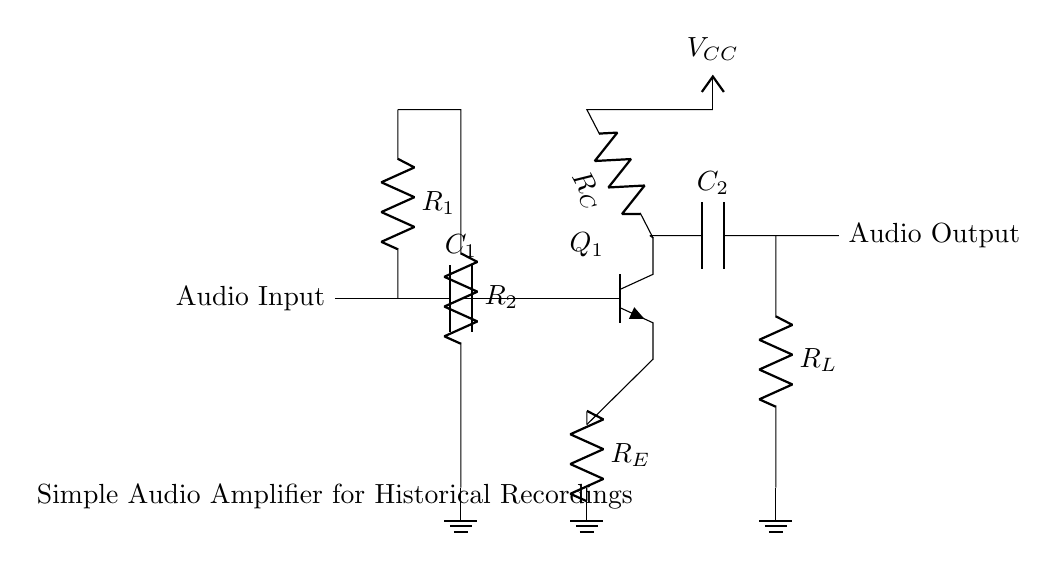What component is used to couple the audio input? The coupling capacitor, labeled as C1, connects the audio input to the transistor, allowing AC signals to pass while blocking DC components.
Answer: C1 What is the configuration of the transistor in this circuit? The circuit includes an NPN transistor (noted as Q1), which is often used in common-emitter configuration for amplification purposes. This setup means the emitter is grounded, and the input is applied at the base for signal amplification.
Answer: NPN What is the role of resistor R_E? R_E, the emitter resistor, helps stabilize the biasing of the transistor by providing negative feedback, which also sets the gain and determines the output impedance of the amplifier.
Answer: Stabilization How many resistors are present in this circuit? The components list shows three resistors: R_E for emitter, R_C for collector, and R_1 and R_2 in the biasing network. Counting gives a total of three resistors overall.
Answer: Three What type of output is suggested in this circuit? The output, denoted as Audio Output, suggests that the circuit is designed to send an amplified audio signal to speakers or other playback equipment, focusing specifically on historical recording reproduction.
Answer: Audio Output What is the function of capacitor C_2? C_2, located at the output, blocks DC voltage from reaching the load while allowing AC signals to pass through, which is crucial for preserving the audio signal integrity in playback.
Answer: AC coupling What is the value of supply voltage mentioned? The circuit indicates a supply voltage labeled as V_CC, but does not define an explicit numerical value; typically, this can range based on design specifics but isn't directly provided here.
Answer: V_CC 